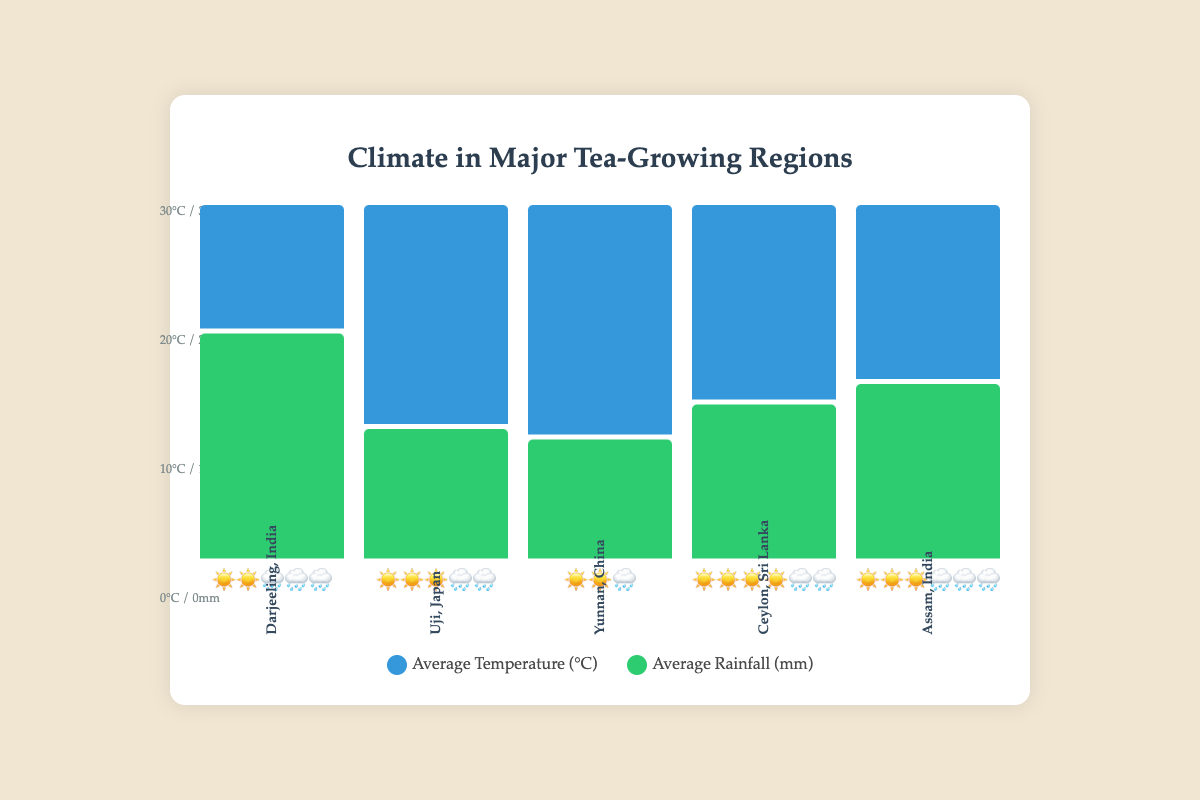What is the title of the chart? The title of the chart is displayed at the top center, saying "Climate in Major Tea-Growing Regions."
Answer: Climate in Major Tea-Growing Regions Which region shows the highest average temperature, and what is that temperature? By looking at the temperature bars and corresponding emojis, the highest temperature can be observed for Ceylon, Sri Lanka, with an average temperature of 27°C.
Answer: Ceylon, Sri Lanka, 27°C Which region has the highest average rainfall, and how much is it? The height of the green rain bars and the number of rain emojis show that Darjeeling, India, has the highest average rainfall at 320mm.
Answer: Darjeeling, India, 320mm What is the difference in average temperature between Uji, Japan, and Yunnan, China? The chart shows Uji, Japan with 22°C (three sun emojis) and Yunnan, China with 18°C (two sun emojis). The difference is calculated as 22 - 18 = 4°C.
Answer: 4°C Which region has equal representations of sun and rain emojis? By examining the emoji representations, Assam, India has three sun emojis and three rain emojis, indicating equal representations of sun and rain emojis.
Answer: Assam, India If we were to rank the regions by average temperature from lowest to highest, what would the order be? Comparing the heights of the blue temperature bars and the associated sun emojis: Darjeeling, India (15°C), Yunnan, China (18°C), Uji, Japan (22°C), Assam, India (24°C), Ceylon, Sri Lanka (27°C) is the order from lowest to highest.
Answer: Darjeeling, India, Yunnan, China, Uji, Japan, Assam, India, Ceylon, Sri Lanka Which two regions have the same number of rain emojis, and what does this represent in terms of rainfall? Examining the number of rain emojis, Uji, Japan, and Ceylon, Sri Lanka both have two rain emojis each, representing average rainfalls of 150mm and 250mm respectively.
Answer: Uji, Japan and Ceylon, Sri Lanka; 150mm and 250mm On average, which is more common in the chart: high temperatures (represented by more sun emojis) or high rainfall (represented by more rain emojis)? Counting the symbols, high temperatures (more sun emojis) appear more frequently: Ceylon (4), Assam (3), Uji (3), Yunnan (2), Darjeeling (2), compared to rain emojis: Darjeeling (3), Assam (3), Uji (2), Ceylon (2), Yunnan (1).
Answer: High temperatures What unique feature in this chart helps to easily identify the climate characteristics of each region? The use of sun and rain emojis along with the height of the blue and green bars visually represents the average temperature and rainfall, making it easy to discern each region's climate characteristics.
Answer: Use of sun and rain emojis 